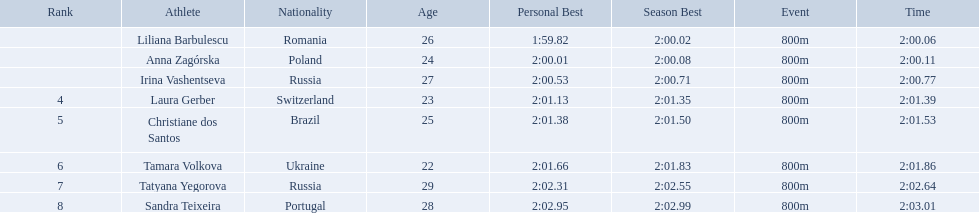Who were the athletes? Liliana Barbulescu, 2:00.06, Anna Zagórska, 2:00.11, Irina Vashentseva, 2:00.77, Laura Gerber, 2:01.39, Christiane dos Santos, 2:01.53, Tamara Volkova, 2:01.86, Tatyana Yegorova, 2:02.64, Sandra Teixeira, 2:03.01. Who received 2nd place? Anna Zagórska, 2:00.11. What was her time? 2:00.11. Who came in second place at the athletics at the 2003 summer universiade - women's 800 metres? Anna Zagórska. What was her time? 2:00.11. Who were the athlete were in the athletics at the 2003 summer universiade - women's 800 metres? , Liliana Barbulescu, Anna Zagórska, Irina Vashentseva, Laura Gerber, Christiane dos Santos, Tamara Volkova, Tatyana Yegorova, Sandra Teixeira. What was anna zagorska finishing time? 2:00.11. What were all the finishing times? 2:00.06, 2:00.11, 2:00.77, 2:01.39, 2:01.53, 2:01.86, 2:02.64, 2:03.01. Which of these is anna zagorska's? 2:00.11. 